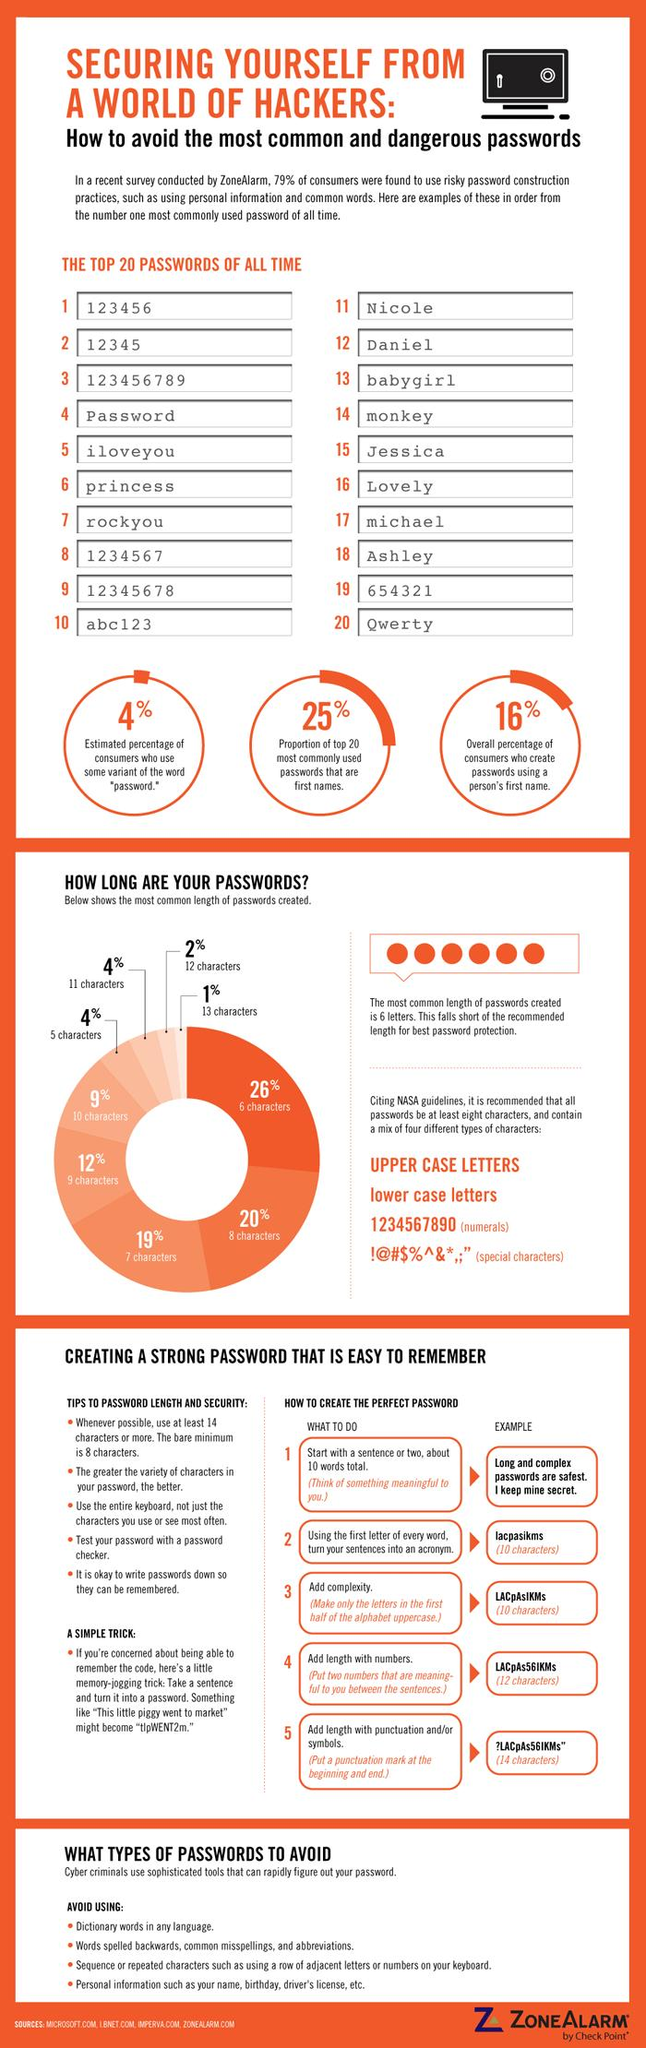List a handful of essential elements in this visual. Only 1% of the passwords created are 13 characters long. Approximately 26% of the passwords created are six characters in length. According to an estimate, only 4% of consumers use some variant of the word "password" when creating passwords. According to a recent survey, approximately 16% of consumers use their first name as the basis for their passwords. Approximately 9% of the passwords created are ten characters in length. 